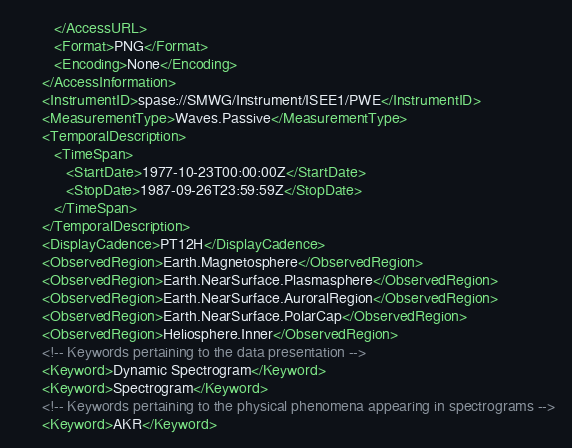Convert code to text. <code><loc_0><loc_0><loc_500><loc_500><_XML_>         </AccessURL>
         <Format>PNG</Format>
         <Encoding>None</Encoding>
      </AccessInformation>
      <InstrumentID>spase://SMWG/Instrument/ISEE1/PWE</InstrumentID>
      <MeasurementType>Waves.Passive</MeasurementType>
      <TemporalDescription>
         <TimeSpan>
            <StartDate>1977-10-23T00:00:00Z</StartDate>
            <StopDate>1987-09-26T23:59:59Z</StopDate>
         </TimeSpan>
      </TemporalDescription>
      <DisplayCadence>PT12H</DisplayCadence>
      <ObservedRegion>Earth.Magnetosphere</ObservedRegion>
      <ObservedRegion>Earth.NearSurface.Plasmasphere</ObservedRegion>
      <ObservedRegion>Earth.NearSurface.AuroralRegion</ObservedRegion>
      <ObservedRegion>Earth.NearSurface.PolarCap</ObservedRegion>
      <ObservedRegion>Heliosphere.Inner</ObservedRegion>
      <!-- Keywords pertaining to the data presentation -->
      <Keyword>Dynamic Spectrogram</Keyword>
      <Keyword>Spectrogram</Keyword>
      <!-- Keywords pertaining to the physical phenomena appearing in spectrograms -->
      <Keyword>AKR</Keyword></code> 